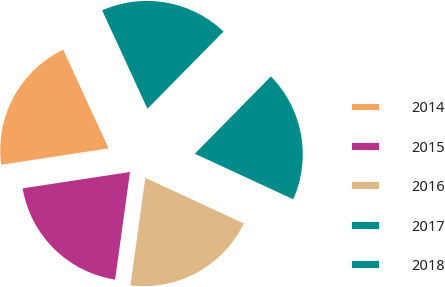Convert chart to OTSL. <chart><loc_0><loc_0><loc_500><loc_500><pie_chart><fcel>2014<fcel>2015<fcel>2016<fcel>2017<fcel>2018<nl><fcel>20.54%<fcel>20.41%<fcel>20.28%<fcel>19.53%<fcel>19.24%<nl></chart> 